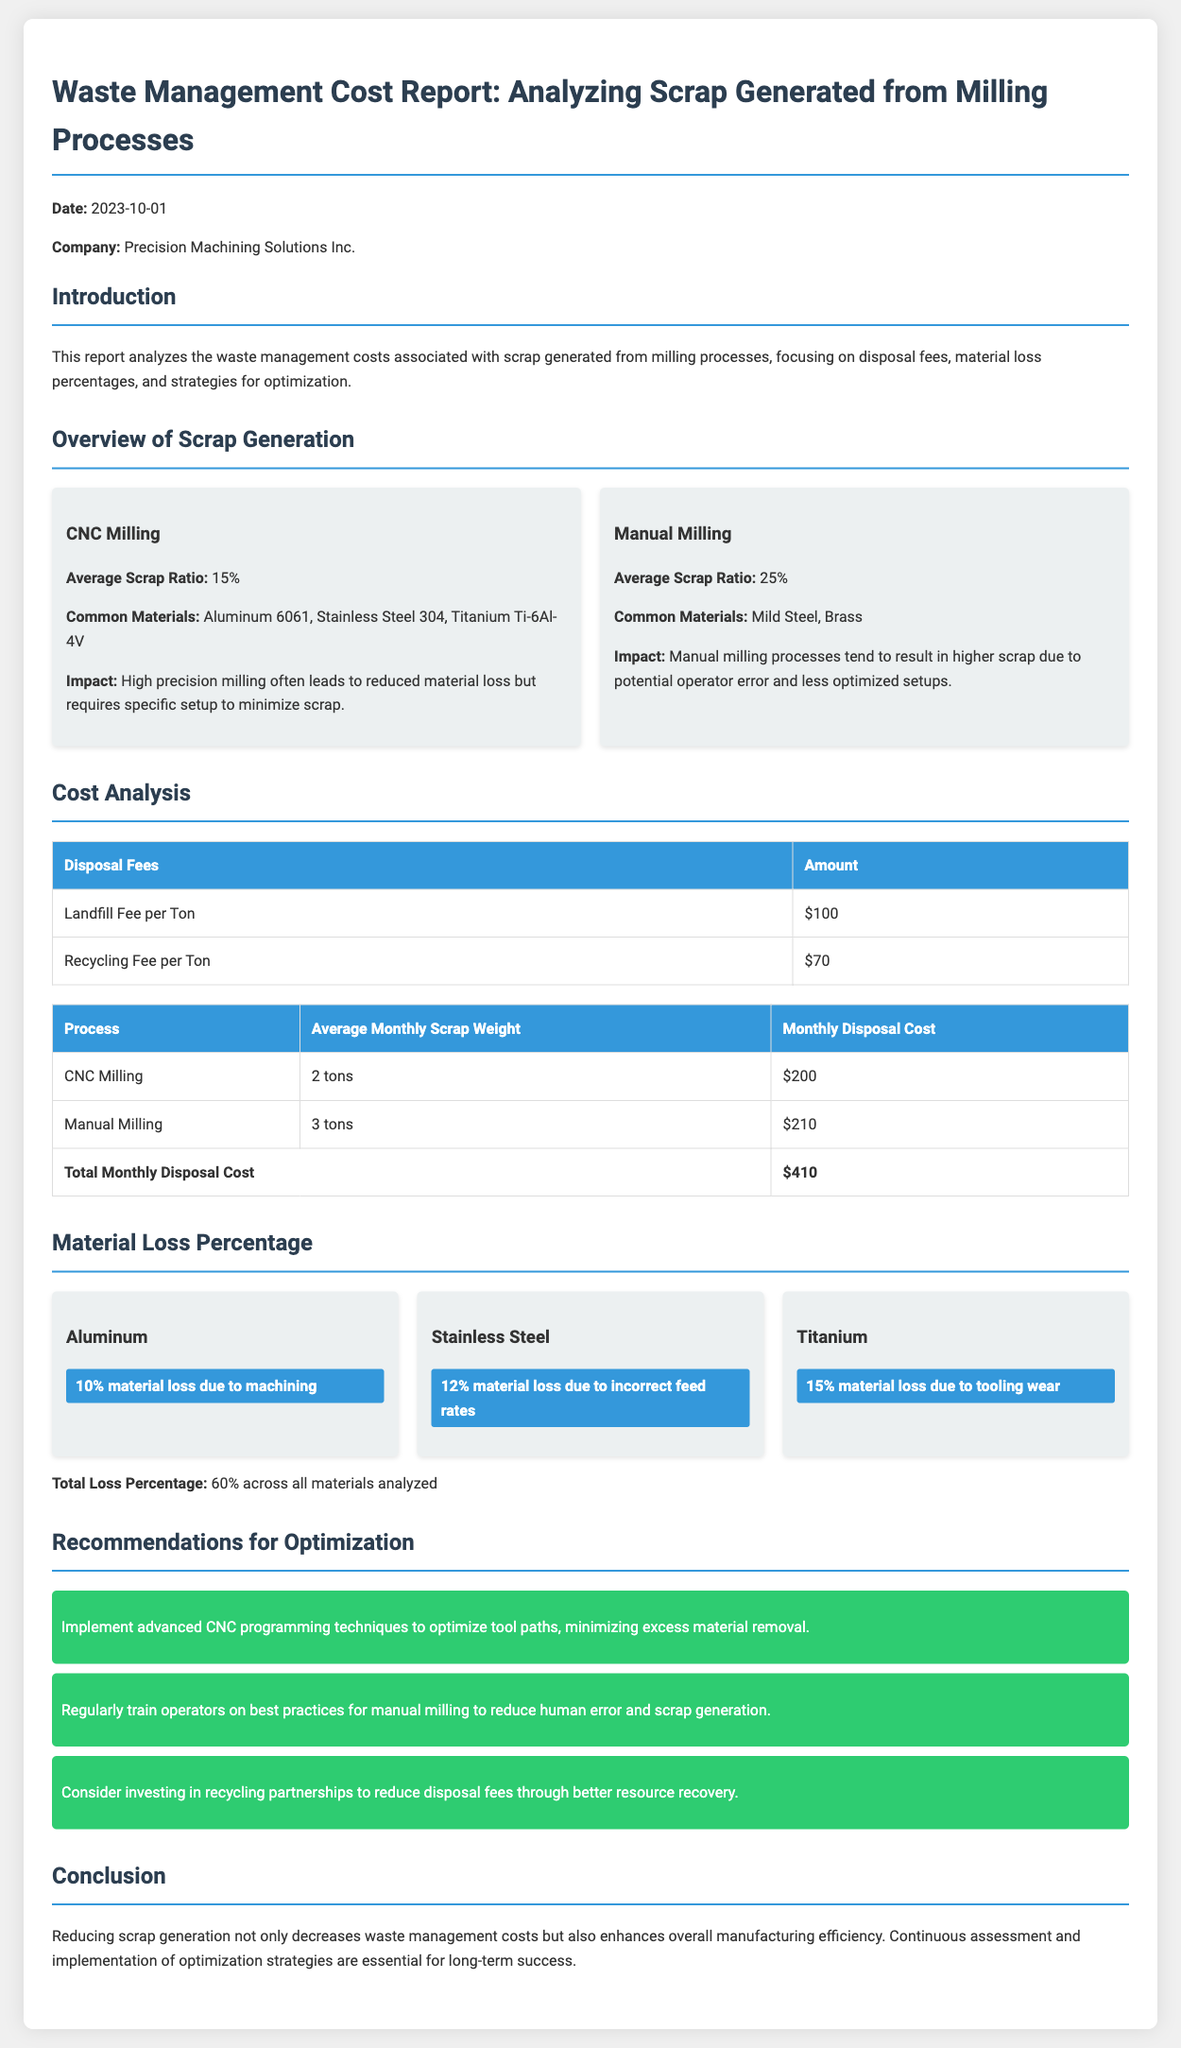What is the average scrap ratio for CNC milling? The average scrap ratio for CNC milling is noted as 15% in the document.
Answer: 15% What is the landfill fee per ton? The landfill fee per ton is specified in the cost analysis section as $100.
Answer: $100 How much is the total monthly disposal cost? The total monthly disposal cost is calculated as the sum of individual process costs, resulting in $410.
Answer: $410 What percentage of material loss is associated with titanium? Titanium has a material loss percentage of 15% due to tooling wear as stated in the document.
Answer: 15% What is recommended to minimize excess material removal in milling processes? It is recommended to implement advanced CNC programming techniques to optimize tool paths.
Answer: Advanced CNC programming techniques What are the common materials used in manual milling? The common materials used in manual milling include Mild Steel and Brass, as mentioned in the overview.
Answer: Mild Steel, Brass How many tons of scrap does CNC milling generate monthly? CNC milling generates an average monthly scrap weight of 2 tons according to the cost analysis.
Answer: 2 tons What percentage of total material loss is noted across all materials analyzed? The total loss percentage across all materials analyzed is stated to be 60%.
Answer: 60% What is one of the suggested strategies to reduce disposal fees? The document suggests considering investing in recycling partnerships to reduce disposal fees.
Answer: Recycling partnerships 